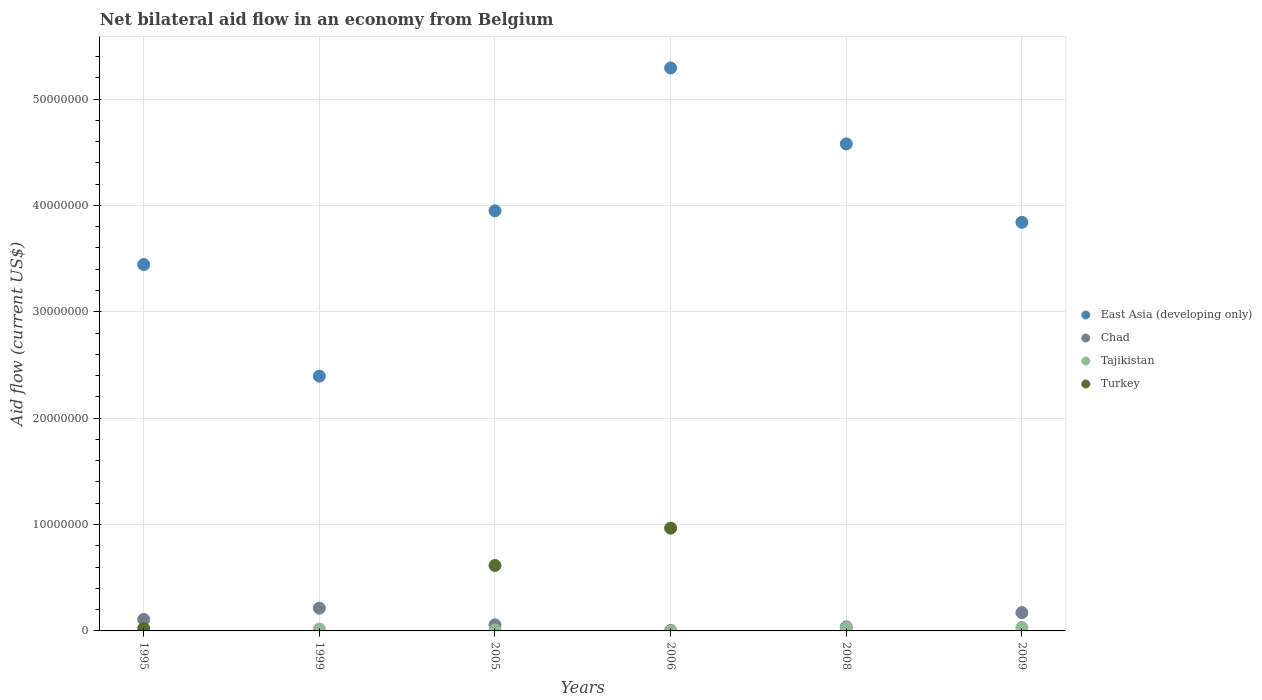How many different coloured dotlines are there?
Ensure brevity in your answer.  4. Is the number of dotlines equal to the number of legend labels?
Give a very brief answer. No. Across all years, what is the maximum net bilateral aid flow in East Asia (developing only)?
Your answer should be very brief. 5.29e+07. Across all years, what is the minimum net bilateral aid flow in East Asia (developing only)?
Give a very brief answer. 2.40e+07. In which year was the net bilateral aid flow in Tajikistan maximum?
Give a very brief answer. 2009. What is the total net bilateral aid flow in East Asia (developing only) in the graph?
Your response must be concise. 2.35e+08. What is the difference between the net bilateral aid flow in Tajikistan in 2005 and that in 2009?
Your answer should be very brief. -2.30e+05. What is the difference between the net bilateral aid flow in Turkey in 1995 and the net bilateral aid flow in Tajikistan in 2009?
Offer a very short reply. -9.00e+04. What is the average net bilateral aid flow in East Asia (developing only) per year?
Provide a succinct answer. 3.92e+07. In the year 2006, what is the difference between the net bilateral aid flow in Turkey and net bilateral aid flow in Tajikistan?
Make the answer very short. 9.65e+06. What is the ratio of the net bilateral aid flow in Chad in 2005 to that in 2008?
Your response must be concise. 1.5. Is the net bilateral aid flow in Tajikistan in 2008 less than that in 2009?
Provide a succinct answer. Yes. What is the difference between the highest and the second highest net bilateral aid flow in Tajikistan?
Keep it short and to the point. 2.00e+04. Is the sum of the net bilateral aid flow in East Asia (developing only) in 1995 and 2008 greater than the maximum net bilateral aid flow in Tajikistan across all years?
Provide a succinct answer. Yes. Is it the case that in every year, the sum of the net bilateral aid flow in Tajikistan and net bilateral aid flow in Chad  is greater than the sum of net bilateral aid flow in East Asia (developing only) and net bilateral aid flow in Turkey?
Your answer should be very brief. No. Is the net bilateral aid flow in Turkey strictly greater than the net bilateral aid flow in Tajikistan over the years?
Ensure brevity in your answer.  No. Is the net bilateral aid flow in East Asia (developing only) strictly less than the net bilateral aid flow in Chad over the years?
Your answer should be very brief. No. How many dotlines are there?
Offer a very short reply. 4. How many years are there in the graph?
Give a very brief answer. 6. Does the graph contain any zero values?
Your response must be concise. Yes. What is the title of the graph?
Your answer should be very brief. Net bilateral aid flow in an economy from Belgium. Does "Equatorial Guinea" appear as one of the legend labels in the graph?
Ensure brevity in your answer.  No. What is the label or title of the Y-axis?
Offer a very short reply. Aid flow (current US$). What is the Aid flow (current US$) of East Asia (developing only) in 1995?
Offer a terse response. 3.44e+07. What is the Aid flow (current US$) in Chad in 1995?
Make the answer very short. 1.08e+06. What is the Aid flow (current US$) in East Asia (developing only) in 1999?
Make the answer very short. 2.40e+07. What is the Aid flow (current US$) in Chad in 1999?
Your answer should be compact. 2.14e+06. What is the Aid flow (current US$) in Tajikistan in 1999?
Your answer should be very brief. 1.80e+05. What is the Aid flow (current US$) of East Asia (developing only) in 2005?
Your answer should be very brief. 3.95e+07. What is the Aid flow (current US$) in Chad in 2005?
Your answer should be very brief. 5.70e+05. What is the Aid flow (current US$) of Turkey in 2005?
Keep it short and to the point. 6.15e+06. What is the Aid flow (current US$) of East Asia (developing only) in 2006?
Keep it short and to the point. 5.29e+07. What is the Aid flow (current US$) of Turkey in 2006?
Ensure brevity in your answer.  9.66e+06. What is the Aid flow (current US$) of East Asia (developing only) in 2008?
Provide a short and direct response. 4.58e+07. What is the Aid flow (current US$) in Tajikistan in 2008?
Keep it short and to the point. 3.00e+05. What is the Aid flow (current US$) in Turkey in 2008?
Keep it short and to the point. 0. What is the Aid flow (current US$) in East Asia (developing only) in 2009?
Your answer should be very brief. 3.84e+07. What is the Aid flow (current US$) of Chad in 2009?
Make the answer very short. 1.72e+06. What is the Aid flow (current US$) in Turkey in 2009?
Provide a short and direct response. 0. Across all years, what is the maximum Aid flow (current US$) in East Asia (developing only)?
Give a very brief answer. 5.29e+07. Across all years, what is the maximum Aid flow (current US$) of Chad?
Keep it short and to the point. 2.14e+06. Across all years, what is the maximum Aid flow (current US$) in Tajikistan?
Offer a terse response. 3.20e+05. Across all years, what is the maximum Aid flow (current US$) in Turkey?
Provide a short and direct response. 9.66e+06. Across all years, what is the minimum Aid flow (current US$) in East Asia (developing only)?
Make the answer very short. 2.40e+07. Across all years, what is the minimum Aid flow (current US$) of Chad?
Keep it short and to the point. 5.00e+04. Across all years, what is the minimum Aid flow (current US$) of Tajikistan?
Your answer should be compact. 10000. Across all years, what is the minimum Aid flow (current US$) of Turkey?
Offer a terse response. 0. What is the total Aid flow (current US$) in East Asia (developing only) in the graph?
Provide a succinct answer. 2.35e+08. What is the total Aid flow (current US$) of Chad in the graph?
Provide a short and direct response. 5.94e+06. What is the total Aid flow (current US$) in Tajikistan in the graph?
Make the answer very short. 9.50e+05. What is the total Aid flow (current US$) in Turkey in the graph?
Offer a very short reply. 1.60e+07. What is the difference between the Aid flow (current US$) of East Asia (developing only) in 1995 and that in 1999?
Your answer should be compact. 1.05e+07. What is the difference between the Aid flow (current US$) in Chad in 1995 and that in 1999?
Give a very brief answer. -1.06e+06. What is the difference between the Aid flow (current US$) of Tajikistan in 1995 and that in 1999?
Your response must be concise. -1.30e+05. What is the difference between the Aid flow (current US$) in East Asia (developing only) in 1995 and that in 2005?
Offer a terse response. -5.05e+06. What is the difference between the Aid flow (current US$) of Chad in 1995 and that in 2005?
Offer a terse response. 5.10e+05. What is the difference between the Aid flow (current US$) in Tajikistan in 1995 and that in 2005?
Offer a terse response. -4.00e+04. What is the difference between the Aid flow (current US$) of Turkey in 1995 and that in 2005?
Offer a terse response. -5.92e+06. What is the difference between the Aid flow (current US$) of East Asia (developing only) in 1995 and that in 2006?
Give a very brief answer. -1.85e+07. What is the difference between the Aid flow (current US$) of Chad in 1995 and that in 2006?
Make the answer very short. 1.03e+06. What is the difference between the Aid flow (current US$) of Turkey in 1995 and that in 2006?
Ensure brevity in your answer.  -9.43e+06. What is the difference between the Aid flow (current US$) of East Asia (developing only) in 1995 and that in 2008?
Offer a very short reply. -1.13e+07. What is the difference between the Aid flow (current US$) in Chad in 1995 and that in 2008?
Your answer should be compact. 7.00e+05. What is the difference between the Aid flow (current US$) in East Asia (developing only) in 1995 and that in 2009?
Offer a very short reply. -3.97e+06. What is the difference between the Aid flow (current US$) in Chad in 1995 and that in 2009?
Offer a very short reply. -6.40e+05. What is the difference between the Aid flow (current US$) in East Asia (developing only) in 1999 and that in 2005?
Offer a very short reply. -1.55e+07. What is the difference between the Aid flow (current US$) of Chad in 1999 and that in 2005?
Keep it short and to the point. 1.57e+06. What is the difference between the Aid flow (current US$) in East Asia (developing only) in 1999 and that in 2006?
Your answer should be very brief. -2.90e+07. What is the difference between the Aid flow (current US$) of Chad in 1999 and that in 2006?
Offer a very short reply. 2.09e+06. What is the difference between the Aid flow (current US$) in East Asia (developing only) in 1999 and that in 2008?
Offer a very short reply. -2.18e+07. What is the difference between the Aid flow (current US$) in Chad in 1999 and that in 2008?
Make the answer very short. 1.76e+06. What is the difference between the Aid flow (current US$) of East Asia (developing only) in 1999 and that in 2009?
Provide a succinct answer. -1.45e+07. What is the difference between the Aid flow (current US$) in Chad in 1999 and that in 2009?
Your response must be concise. 4.20e+05. What is the difference between the Aid flow (current US$) in East Asia (developing only) in 2005 and that in 2006?
Make the answer very short. -1.34e+07. What is the difference between the Aid flow (current US$) of Chad in 2005 and that in 2006?
Offer a very short reply. 5.20e+05. What is the difference between the Aid flow (current US$) in Tajikistan in 2005 and that in 2006?
Your answer should be compact. 8.00e+04. What is the difference between the Aid flow (current US$) in Turkey in 2005 and that in 2006?
Ensure brevity in your answer.  -3.51e+06. What is the difference between the Aid flow (current US$) in East Asia (developing only) in 2005 and that in 2008?
Keep it short and to the point. -6.29e+06. What is the difference between the Aid flow (current US$) in Tajikistan in 2005 and that in 2008?
Give a very brief answer. -2.10e+05. What is the difference between the Aid flow (current US$) in East Asia (developing only) in 2005 and that in 2009?
Provide a short and direct response. 1.08e+06. What is the difference between the Aid flow (current US$) of Chad in 2005 and that in 2009?
Provide a short and direct response. -1.15e+06. What is the difference between the Aid flow (current US$) of East Asia (developing only) in 2006 and that in 2008?
Offer a very short reply. 7.14e+06. What is the difference between the Aid flow (current US$) of Chad in 2006 and that in 2008?
Your answer should be compact. -3.30e+05. What is the difference between the Aid flow (current US$) in Tajikistan in 2006 and that in 2008?
Offer a terse response. -2.90e+05. What is the difference between the Aid flow (current US$) of East Asia (developing only) in 2006 and that in 2009?
Offer a terse response. 1.45e+07. What is the difference between the Aid flow (current US$) in Chad in 2006 and that in 2009?
Keep it short and to the point. -1.67e+06. What is the difference between the Aid flow (current US$) in Tajikistan in 2006 and that in 2009?
Your answer should be compact. -3.10e+05. What is the difference between the Aid flow (current US$) in East Asia (developing only) in 2008 and that in 2009?
Provide a short and direct response. 7.37e+06. What is the difference between the Aid flow (current US$) of Chad in 2008 and that in 2009?
Offer a terse response. -1.34e+06. What is the difference between the Aid flow (current US$) of Tajikistan in 2008 and that in 2009?
Give a very brief answer. -2.00e+04. What is the difference between the Aid flow (current US$) of East Asia (developing only) in 1995 and the Aid flow (current US$) of Chad in 1999?
Provide a short and direct response. 3.23e+07. What is the difference between the Aid flow (current US$) in East Asia (developing only) in 1995 and the Aid flow (current US$) in Tajikistan in 1999?
Provide a succinct answer. 3.43e+07. What is the difference between the Aid flow (current US$) in East Asia (developing only) in 1995 and the Aid flow (current US$) in Chad in 2005?
Provide a succinct answer. 3.39e+07. What is the difference between the Aid flow (current US$) in East Asia (developing only) in 1995 and the Aid flow (current US$) in Tajikistan in 2005?
Your response must be concise. 3.44e+07. What is the difference between the Aid flow (current US$) of East Asia (developing only) in 1995 and the Aid flow (current US$) of Turkey in 2005?
Give a very brief answer. 2.83e+07. What is the difference between the Aid flow (current US$) in Chad in 1995 and the Aid flow (current US$) in Tajikistan in 2005?
Keep it short and to the point. 9.90e+05. What is the difference between the Aid flow (current US$) of Chad in 1995 and the Aid flow (current US$) of Turkey in 2005?
Keep it short and to the point. -5.07e+06. What is the difference between the Aid flow (current US$) of Tajikistan in 1995 and the Aid flow (current US$) of Turkey in 2005?
Give a very brief answer. -6.10e+06. What is the difference between the Aid flow (current US$) of East Asia (developing only) in 1995 and the Aid flow (current US$) of Chad in 2006?
Offer a very short reply. 3.44e+07. What is the difference between the Aid flow (current US$) in East Asia (developing only) in 1995 and the Aid flow (current US$) in Tajikistan in 2006?
Provide a succinct answer. 3.44e+07. What is the difference between the Aid flow (current US$) in East Asia (developing only) in 1995 and the Aid flow (current US$) in Turkey in 2006?
Offer a very short reply. 2.48e+07. What is the difference between the Aid flow (current US$) in Chad in 1995 and the Aid flow (current US$) in Tajikistan in 2006?
Ensure brevity in your answer.  1.07e+06. What is the difference between the Aid flow (current US$) in Chad in 1995 and the Aid flow (current US$) in Turkey in 2006?
Offer a terse response. -8.58e+06. What is the difference between the Aid flow (current US$) in Tajikistan in 1995 and the Aid flow (current US$) in Turkey in 2006?
Give a very brief answer. -9.61e+06. What is the difference between the Aid flow (current US$) of East Asia (developing only) in 1995 and the Aid flow (current US$) of Chad in 2008?
Keep it short and to the point. 3.41e+07. What is the difference between the Aid flow (current US$) in East Asia (developing only) in 1995 and the Aid flow (current US$) in Tajikistan in 2008?
Your answer should be very brief. 3.41e+07. What is the difference between the Aid flow (current US$) in Chad in 1995 and the Aid flow (current US$) in Tajikistan in 2008?
Offer a very short reply. 7.80e+05. What is the difference between the Aid flow (current US$) in East Asia (developing only) in 1995 and the Aid flow (current US$) in Chad in 2009?
Your answer should be very brief. 3.27e+07. What is the difference between the Aid flow (current US$) in East Asia (developing only) in 1995 and the Aid flow (current US$) in Tajikistan in 2009?
Give a very brief answer. 3.41e+07. What is the difference between the Aid flow (current US$) of Chad in 1995 and the Aid flow (current US$) of Tajikistan in 2009?
Your answer should be compact. 7.60e+05. What is the difference between the Aid flow (current US$) in East Asia (developing only) in 1999 and the Aid flow (current US$) in Chad in 2005?
Make the answer very short. 2.34e+07. What is the difference between the Aid flow (current US$) in East Asia (developing only) in 1999 and the Aid flow (current US$) in Tajikistan in 2005?
Offer a very short reply. 2.39e+07. What is the difference between the Aid flow (current US$) in East Asia (developing only) in 1999 and the Aid flow (current US$) in Turkey in 2005?
Provide a short and direct response. 1.78e+07. What is the difference between the Aid flow (current US$) in Chad in 1999 and the Aid flow (current US$) in Tajikistan in 2005?
Your response must be concise. 2.05e+06. What is the difference between the Aid flow (current US$) of Chad in 1999 and the Aid flow (current US$) of Turkey in 2005?
Your response must be concise. -4.01e+06. What is the difference between the Aid flow (current US$) in Tajikistan in 1999 and the Aid flow (current US$) in Turkey in 2005?
Make the answer very short. -5.97e+06. What is the difference between the Aid flow (current US$) in East Asia (developing only) in 1999 and the Aid flow (current US$) in Chad in 2006?
Your answer should be very brief. 2.39e+07. What is the difference between the Aid flow (current US$) of East Asia (developing only) in 1999 and the Aid flow (current US$) of Tajikistan in 2006?
Your answer should be compact. 2.39e+07. What is the difference between the Aid flow (current US$) of East Asia (developing only) in 1999 and the Aid flow (current US$) of Turkey in 2006?
Provide a succinct answer. 1.43e+07. What is the difference between the Aid flow (current US$) in Chad in 1999 and the Aid flow (current US$) in Tajikistan in 2006?
Keep it short and to the point. 2.13e+06. What is the difference between the Aid flow (current US$) in Chad in 1999 and the Aid flow (current US$) in Turkey in 2006?
Provide a succinct answer. -7.52e+06. What is the difference between the Aid flow (current US$) of Tajikistan in 1999 and the Aid flow (current US$) of Turkey in 2006?
Give a very brief answer. -9.48e+06. What is the difference between the Aid flow (current US$) of East Asia (developing only) in 1999 and the Aid flow (current US$) of Chad in 2008?
Provide a succinct answer. 2.36e+07. What is the difference between the Aid flow (current US$) in East Asia (developing only) in 1999 and the Aid flow (current US$) in Tajikistan in 2008?
Your answer should be compact. 2.36e+07. What is the difference between the Aid flow (current US$) of Chad in 1999 and the Aid flow (current US$) of Tajikistan in 2008?
Ensure brevity in your answer.  1.84e+06. What is the difference between the Aid flow (current US$) in East Asia (developing only) in 1999 and the Aid flow (current US$) in Chad in 2009?
Your answer should be very brief. 2.22e+07. What is the difference between the Aid flow (current US$) in East Asia (developing only) in 1999 and the Aid flow (current US$) in Tajikistan in 2009?
Give a very brief answer. 2.36e+07. What is the difference between the Aid flow (current US$) in Chad in 1999 and the Aid flow (current US$) in Tajikistan in 2009?
Provide a short and direct response. 1.82e+06. What is the difference between the Aid flow (current US$) of East Asia (developing only) in 2005 and the Aid flow (current US$) of Chad in 2006?
Give a very brief answer. 3.94e+07. What is the difference between the Aid flow (current US$) in East Asia (developing only) in 2005 and the Aid flow (current US$) in Tajikistan in 2006?
Provide a short and direct response. 3.95e+07. What is the difference between the Aid flow (current US$) of East Asia (developing only) in 2005 and the Aid flow (current US$) of Turkey in 2006?
Ensure brevity in your answer.  2.98e+07. What is the difference between the Aid flow (current US$) of Chad in 2005 and the Aid flow (current US$) of Tajikistan in 2006?
Offer a terse response. 5.60e+05. What is the difference between the Aid flow (current US$) in Chad in 2005 and the Aid flow (current US$) in Turkey in 2006?
Make the answer very short. -9.09e+06. What is the difference between the Aid flow (current US$) in Tajikistan in 2005 and the Aid flow (current US$) in Turkey in 2006?
Your answer should be very brief. -9.57e+06. What is the difference between the Aid flow (current US$) of East Asia (developing only) in 2005 and the Aid flow (current US$) of Chad in 2008?
Your answer should be very brief. 3.91e+07. What is the difference between the Aid flow (current US$) in East Asia (developing only) in 2005 and the Aid flow (current US$) in Tajikistan in 2008?
Provide a short and direct response. 3.92e+07. What is the difference between the Aid flow (current US$) in Chad in 2005 and the Aid flow (current US$) in Tajikistan in 2008?
Offer a very short reply. 2.70e+05. What is the difference between the Aid flow (current US$) of East Asia (developing only) in 2005 and the Aid flow (current US$) of Chad in 2009?
Provide a succinct answer. 3.78e+07. What is the difference between the Aid flow (current US$) of East Asia (developing only) in 2005 and the Aid flow (current US$) of Tajikistan in 2009?
Offer a very short reply. 3.92e+07. What is the difference between the Aid flow (current US$) of East Asia (developing only) in 2006 and the Aid flow (current US$) of Chad in 2008?
Provide a short and direct response. 5.25e+07. What is the difference between the Aid flow (current US$) of East Asia (developing only) in 2006 and the Aid flow (current US$) of Tajikistan in 2008?
Offer a very short reply. 5.26e+07. What is the difference between the Aid flow (current US$) in East Asia (developing only) in 2006 and the Aid flow (current US$) in Chad in 2009?
Provide a succinct answer. 5.12e+07. What is the difference between the Aid flow (current US$) of East Asia (developing only) in 2006 and the Aid flow (current US$) of Tajikistan in 2009?
Provide a short and direct response. 5.26e+07. What is the difference between the Aid flow (current US$) in East Asia (developing only) in 2008 and the Aid flow (current US$) in Chad in 2009?
Your response must be concise. 4.41e+07. What is the difference between the Aid flow (current US$) in East Asia (developing only) in 2008 and the Aid flow (current US$) in Tajikistan in 2009?
Give a very brief answer. 4.55e+07. What is the difference between the Aid flow (current US$) in Chad in 2008 and the Aid flow (current US$) in Tajikistan in 2009?
Your answer should be compact. 6.00e+04. What is the average Aid flow (current US$) in East Asia (developing only) per year?
Provide a succinct answer. 3.92e+07. What is the average Aid flow (current US$) in Chad per year?
Provide a short and direct response. 9.90e+05. What is the average Aid flow (current US$) of Tajikistan per year?
Offer a very short reply. 1.58e+05. What is the average Aid flow (current US$) of Turkey per year?
Offer a very short reply. 2.67e+06. In the year 1995, what is the difference between the Aid flow (current US$) of East Asia (developing only) and Aid flow (current US$) of Chad?
Provide a succinct answer. 3.34e+07. In the year 1995, what is the difference between the Aid flow (current US$) in East Asia (developing only) and Aid flow (current US$) in Tajikistan?
Offer a terse response. 3.44e+07. In the year 1995, what is the difference between the Aid flow (current US$) of East Asia (developing only) and Aid flow (current US$) of Turkey?
Offer a very short reply. 3.42e+07. In the year 1995, what is the difference between the Aid flow (current US$) in Chad and Aid flow (current US$) in Tajikistan?
Give a very brief answer. 1.03e+06. In the year 1995, what is the difference between the Aid flow (current US$) in Chad and Aid flow (current US$) in Turkey?
Ensure brevity in your answer.  8.50e+05. In the year 1999, what is the difference between the Aid flow (current US$) in East Asia (developing only) and Aid flow (current US$) in Chad?
Offer a terse response. 2.18e+07. In the year 1999, what is the difference between the Aid flow (current US$) of East Asia (developing only) and Aid flow (current US$) of Tajikistan?
Make the answer very short. 2.38e+07. In the year 1999, what is the difference between the Aid flow (current US$) of Chad and Aid flow (current US$) of Tajikistan?
Ensure brevity in your answer.  1.96e+06. In the year 2005, what is the difference between the Aid flow (current US$) in East Asia (developing only) and Aid flow (current US$) in Chad?
Your answer should be very brief. 3.89e+07. In the year 2005, what is the difference between the Aid flow (current US$) in East Asia (developing only) and Aid flow (current US$) in Tajikistan?
Your answer should be very brief. 3.94e+07. In the year 2005, what is the difference between the Aid flow (current US$) in East Asia (developing only) and Aid flow (current US$) in Turkey?
Your answer should be very brief. 3.33e+07. In the year 2005, what is the difference between the Aid flow (current US$) of Chad and Aid flow (current US$) of Turkey?
Offer a terse response. -5.58e+06. In the year 2005, what is the difference between the Aid flow (current US$) in Tajikistan and Aid flow (current US$) in Turkey?
Offer a terse response. -6.06e+06. In the year 2006, what is the difference between the Aid flow (current US$) of East Asia (developing only) and Aid flow (current US$) of Chad?
Give a very brief answer. 5.29e+07. In the year 2006, what is the difference between the Aid flow (current US$) of East Asia (developing only) and Aid flow (current US$) of Tajikistan?
Provide a succinct answer. 5.29e+07. In the year 2006, what is the difference between the Aid flow (current US$) in East Asia (developing only) and Aid flow (current US$) in Turkey?
Your response must be concise. 4.33e+07. In the year 2006, what is the difference between the Aid flow (current US$) in Chad and Aid flow (current US$) in Tajikistan?
Your response must be concise. 4.00e+04. In the year 2006, what is the difference between the Aid flow (current US$) in Chad and Aid flow (current US$) in Turkey?
Your answer should be very brief. -9.61e+06. In the year 2006, what is the difference between the Aid flow (current US$) in Tajikistan and Aid flow (current US$) in Turkey?
Ensure brevity in your answer.  -9.65e+06. In the year 2008, what is the difference between the Aid flow (current US$) of East Asia (developing only) and Aid flow (current US$) of Chad?
Your answer should be compact. 4.54e+07. In the year 2008, what is the difference between the Aid flow (current US$) in East Asia (developing only) and Aid flow (current US$) in Tajikistan?
Your response must be concise. 4.55e+07. In the year 2008, what is the difference between the Aid flow (current US$) of Chad and Aid flow (current US$) of Tajikistan?
Give a very brief answer. 8.00e+04. In the year 2009, what is the difference between the Aid flow (current US$) of East Asia (developing only) and Aid flow (current US$) of Chad?
Give a very brief answer. 3.67e+07. In the year 2009, what is the difference between the Aid flow (current US$) in East Asia (developing only) and Aid flow (current US$) in Tajikistan?
Your answer should be compact. 3.81e+07. In the year 2009, what is the difference between the Aid flow (current US$) of Chad and Aid flow (current US$) of Tajikistan?
Provide a succinct answer. 1.40e+06. What is the ratio of the Aid flow (current US$) in East Asia (developing only) in 1995 to that in 1999?
Provide a succinct answer. 1.44. What is the ratio of the Aid flow (current US$) in Chad in 1995 to that in 1999?
Your response must be concise. 0.5. What is the ratio of the Aid flow (current US$) in Tajikistan in 1995 to that in 1999?
Your answer should be very brief. 0.28. What is the ratio of the Aid flow (current US$) in East Asia (developing only) in 1995 to that in 2005?
Give a very brief answer. 0.87. What is the ratio of the Aid flow (current US$) in Chad in 1995 to that in 2005?
Offer a very short reply. 1.89. What is the ratio of the Aid flow (current US$) of Tajikistan in 1995 to that in 2005?
Provide a succinct answer. 0.56. What is the ratio of the Aid flow (current US$) of Turkey in 1995 to that in 2005?
Keep it short and to the point. 0.04. What is the ratio of the Aid flow (current US$) of East Asia (developing only) in 1995 to that in 2006?
Keep it short and to the point. 0.65. What is the ratio of the Aid flow (current US$) of Chad in 1995 to that in 2006?
Make the answer very short. 21.6. What is the ratio of the Aid flow (current US$) of Tajikistan in 1995 to that in 2006?
Ensure brevity in your answer.  5. What is the ratio of the Aid flow (current US$) of Turkey in 1995 to that in 2006?
Keep it short and to the point. 0.02. What is the ratio of the Aid flow (current US$) in East Asia (developing only) in 1995 to that in 2008?
Your answer should be very brief. 0.75. What is the ratio of the Aid flow (current US$) in Chad in 1995 to that in 2008?
Give a very brief answer. 2.84. What is the ratio of the Aid flow (current US$) in Tajikistan in 1995 to that in 2008?
Provide a short and direct response. 0.17. What is the ratio of the Aid flow (current US$) of East Asia (developing only) in 1995 to that in 2009?
Keep it short and to the point. 0.9. What is the ratio of the Aid flow (current US$) of Chad in 1995 to that in 2009?
Your answer should be very brief. 0.63. What is the ratio of the Aid flow (current US$) of Tajikistan in 1995 to that in 2009?
Offer a terse response. 0.16. What is the ratio of the Aid flow (current US$) of East Asia (developing only) in 1999 to that in 2005?
Make the answer very short. 0.61. What is the ratio of the Aid flow (current US$) in Chad in 1999 to that in 2005?
Offer a very short reply. 3.75. What is the ratio of the Aid flow (current US$) in East Asia (developing only) in 1999 to that in 2006?
Ensure brevity in your answer.  0.45. What is the ratio of the Aid flow (current US$) of Chad in 1999 to that in 2006?
Your response must be concise. 42.8. What is the ratio of the Aid flow (current US$) of Tajikistan in 1999 to that in 2006?
Provide a short and direct response. 18. What is the ratio of the Aid flow (current US$) of East Asia (developing only) in 1999 to that in 2008?
Offer a terse response. 0.52. What is the ratio of the Aid flow (current US$) in Chad in 1999 to that in 2008?
Make the answer very short. 5.63. What is the ratio of the Aid flow (current US$) in Tajikistan in 1999 to that in 2008?
Your answer should be compact. 0.6. What is the ratio of the Aid flow (current US$) in East Asia (developing only) in 1999 to that in 2009?
Give a very brief answer. 0.62. What is the ratio of the Aid flow (current US$) in Chad in 1999 to that in 2009?
Ensure brevity in your answer.  1.24. What is the ratio of the Aid flow (current US$) in Tajikistan in 1999 to that in 2009?
Make the answer very short. 0.56. What is the ratio of the Aid flow (current US$) of East Asia (developing only) in 2005 to that in 2006?
Offer a very short reply. 0.75. What is the ratio of the Aid flow (current US$) of Chad in 2005 to that in 2006?
Your response must be concise. 11.4. What is the ratio of the Aid flow (current US$) of Tajikistan in 2005 to that in 2006?
Provide a succinct answer. 9. What is the ratio of the Aid flow (current US$) of Turkey in 2005 to that in 2006?
Your answer should be very brief. 0.64. What is the ratio of the Aid flow (current US$) in East Asia (developing only) in 2005 to that in 2008?
Offer a very short reply. 0.86. What is the ratio of the Aid flow (current US$) in Tajikistan in 2005 to that in 2008?
Your response must be concise. 0.3. What is the ratio of the Aid flow (current US$) in East Asia (developing only) in 2005 to that in 2009?
Provide a short and direct response. 1.03. What is the ratio of the Aid flow (current US$) of Chad in 2005 to that in 2009?
Ensure brevity in your answer.  0.33. What is the ratio of the Aid flow (current US$) of Tajikistan in 2005 to that in 2009?
Give a very brief answer. 0.28. What is the ratio of the Aid flow (current US$) in East Asia (developing only) in 2006 to that in 2008?
Give a very brief answer. 1.16. What is the ratio of the Aid flow (current US$) of Chad in 2006 to that in 2008?
Your answer should be very brief. 0.13. What is the ratio of the Aid flow (current US$) in East Asia (developing only) in 2006 to that in 2009?
Your answer should be compact. 1.38. What is the ratio of the Aid flow (current US$) in Chad in 2006 to that in 2009?
Offer a terse response. 0.03. What is the ratio of the Aid flow (current US$) in Tajikistan in 2006 to that in 2009?
Your answer should be very brief. 0.03. What is the ratio of the Aid flow (current US$) in East Asia (developing only) in 2008 to that in 2009?
Keep it short and to the point. 1.19. What is the ratio of the Aid flow (current US$) in Chad in 2008 to that in 2009?
Offer a very short reply. 0.22. What is the difference between the highest and the second highest Aid flow (current US$) of East Asia (developing only)?
Ensure brevity in your answer.  7.14e+06. What is the difference between the highest and the second highest Aid flow (current US$) of Turkey?
Provide a short and direct response. 3.51e+06. What is the difference between the highest and the lowest Aid flow (current US$) of East Asia (developing only)?
Make the answer very short. 2.90e+07. What is the difference between the highest and the lowest Aid flow (current US$) of Chad?
Provide a short and direct response. 2.09e+06. What is the difference between the highest and the lowest Aid flow (current US$) of Turkey?
Make the answer very short. 9.66e+06. 